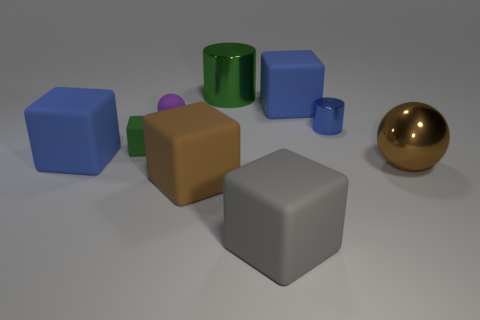Subtract 1 blocks. How many blocks are left? 4 Subtract all green blocks. How many blocks are left? 4 Subtract all green rubber cubes. How many cubes are left? 4 Subtract all yellow cylinders. Subtract all green blocks. How many cylinders are left? 2 Subtract all cubes. How many objects are left? 4 Subtract all gray matte blocks. Subtract all blue cylinders. How many objects are left? 7 Add 3 big brown objects. How many big brown objects are left? 5 Add 1 green blocks. How many green blocks exist? 2 Subtract 0 brown cylinders. How many objects are left? 9 